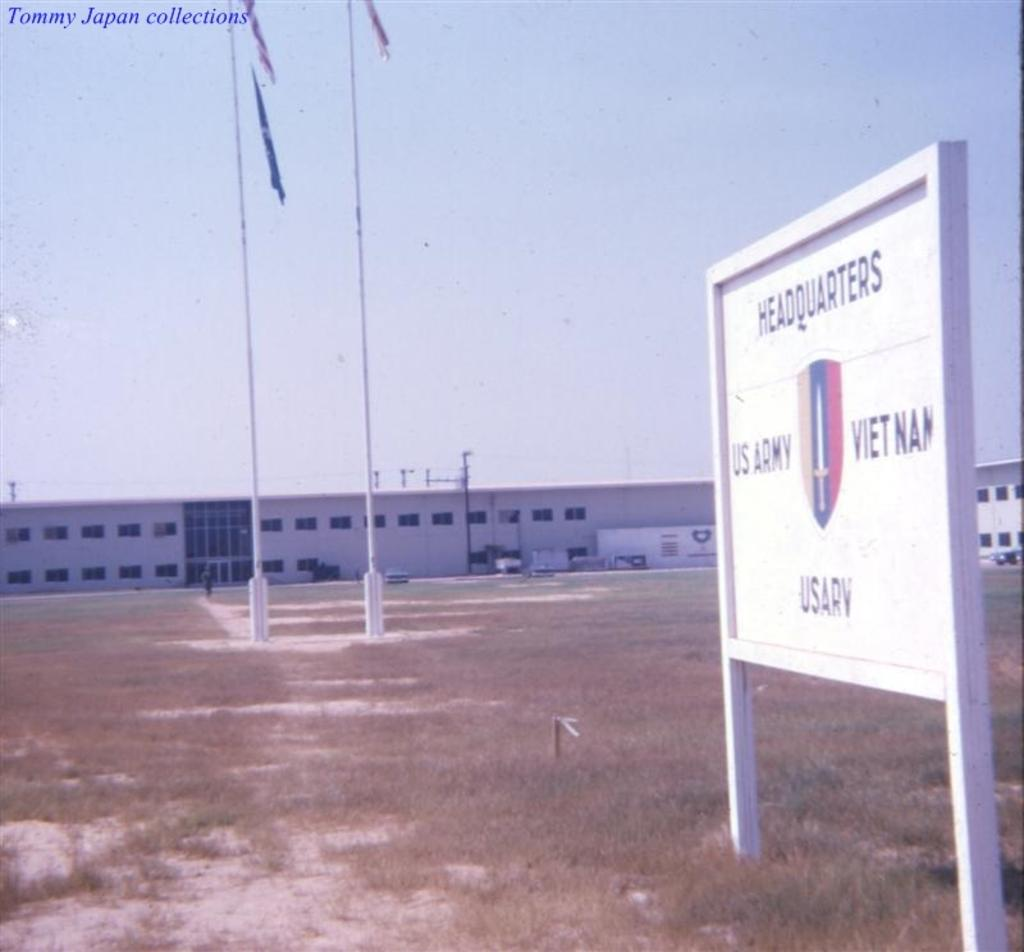Provide a one-sentence caption for the provided image. A sign identifies a low building as a US Army Headquarters location. 